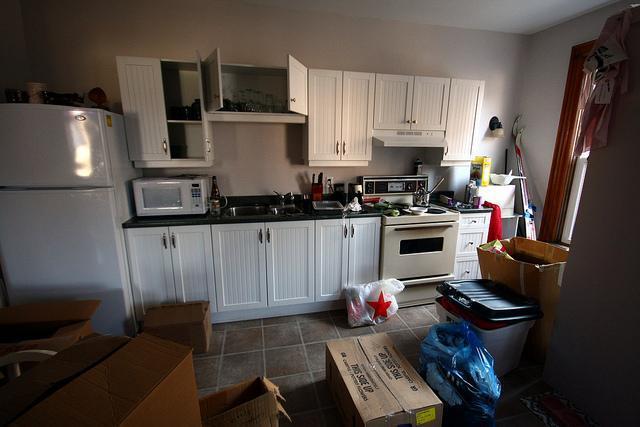How many cabinet doors are open?
Give a very brief answer. 3. How many bags on the floor?
Give a very brief answer. 2. How many people rowing are wearing bright green?
Give a very brief answer. 0. 